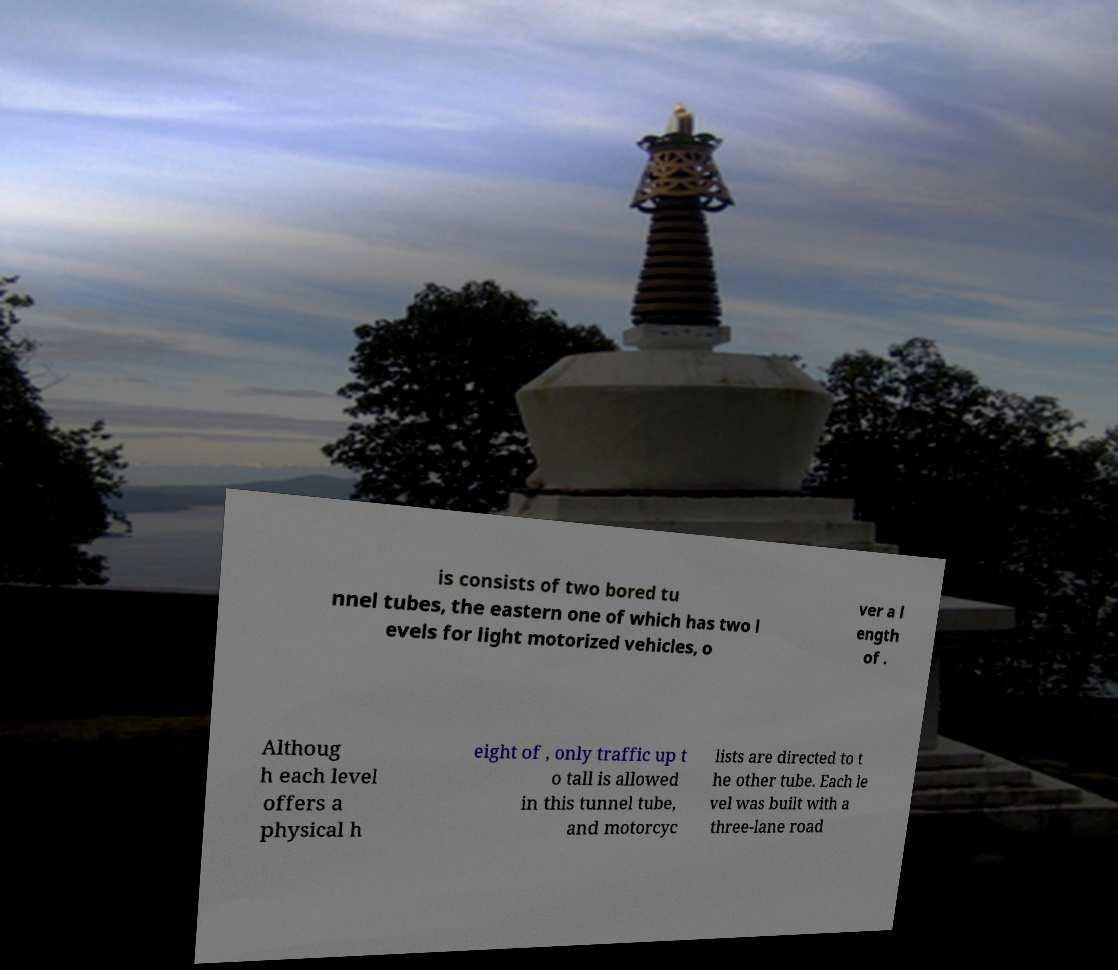I need the written content from this picture converted into text. Can you do that? is consists of two bored tu nnel tubes, the eastern one of which has two l evels for light motorized vehicles, o ver a l ength of . Althoug h each level offers a physical h eight of , only traffic up t o tall is allowed in this tunnel tube, and motorcyc lists are directed to t he other tube. Each le vel was built with a three-lane road 